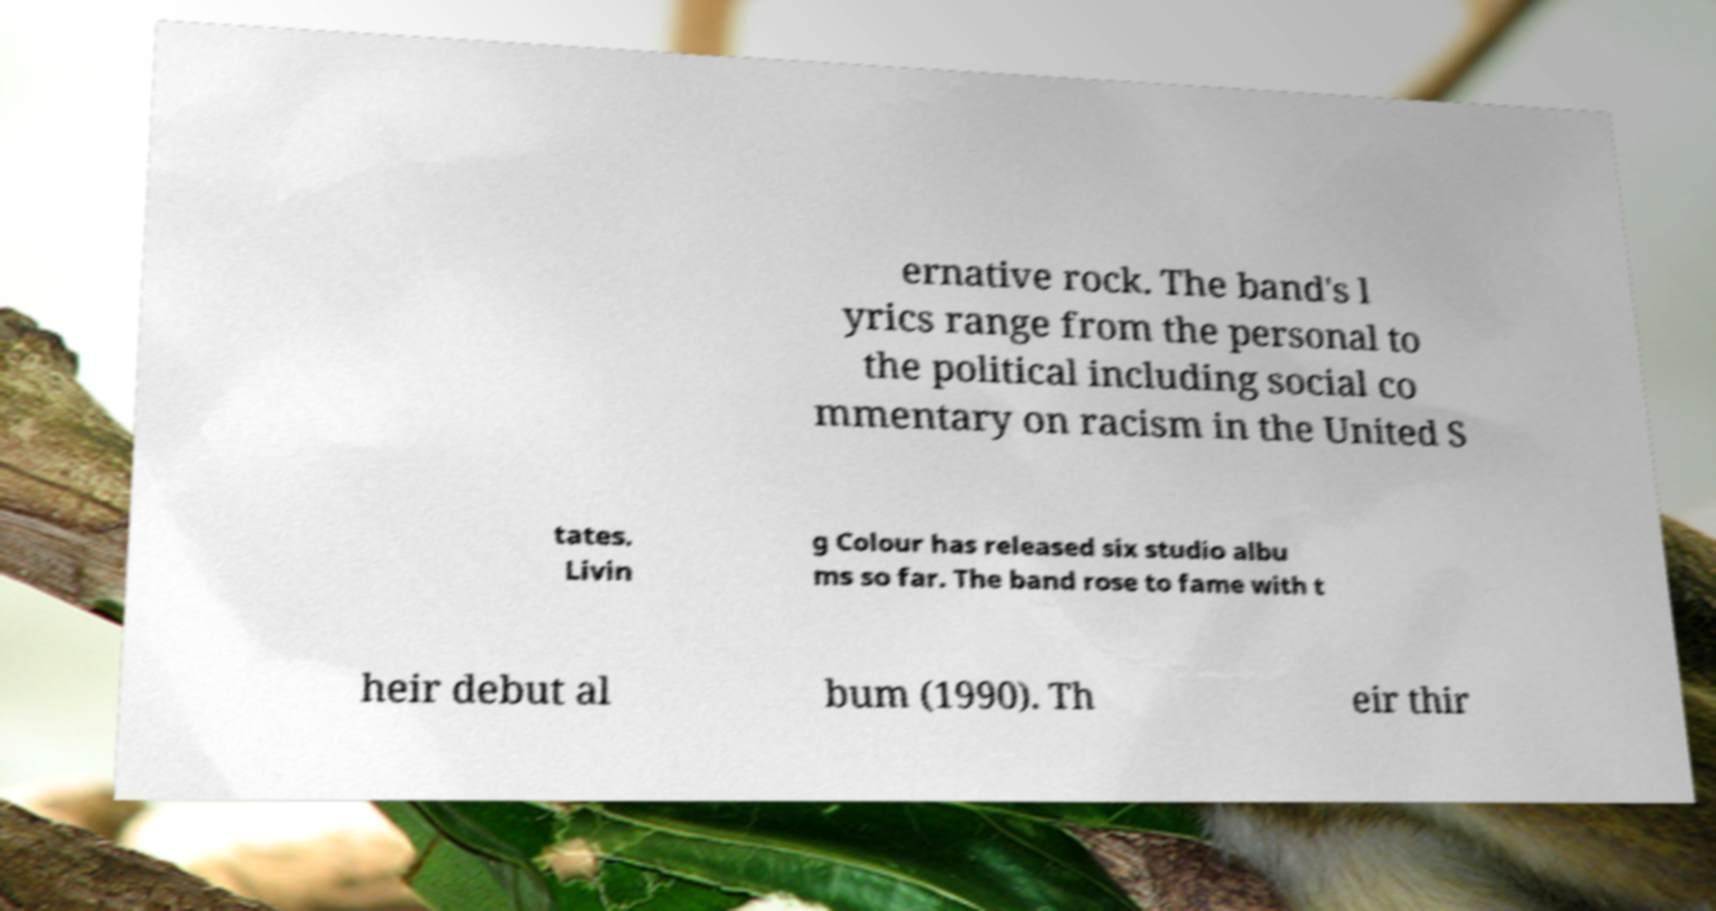Can you read and provide the text displayed in the image?This photo seems to have some interesting text. Can you extract and type it out for me? ernative rock. The band's l yrics range from the personal to the political including social co mmentary on racism in the United S tates. Livin g Colour has released six studio albu ms so far. The band rose to fame with t heir debut al bum (1990). Th eir thir 